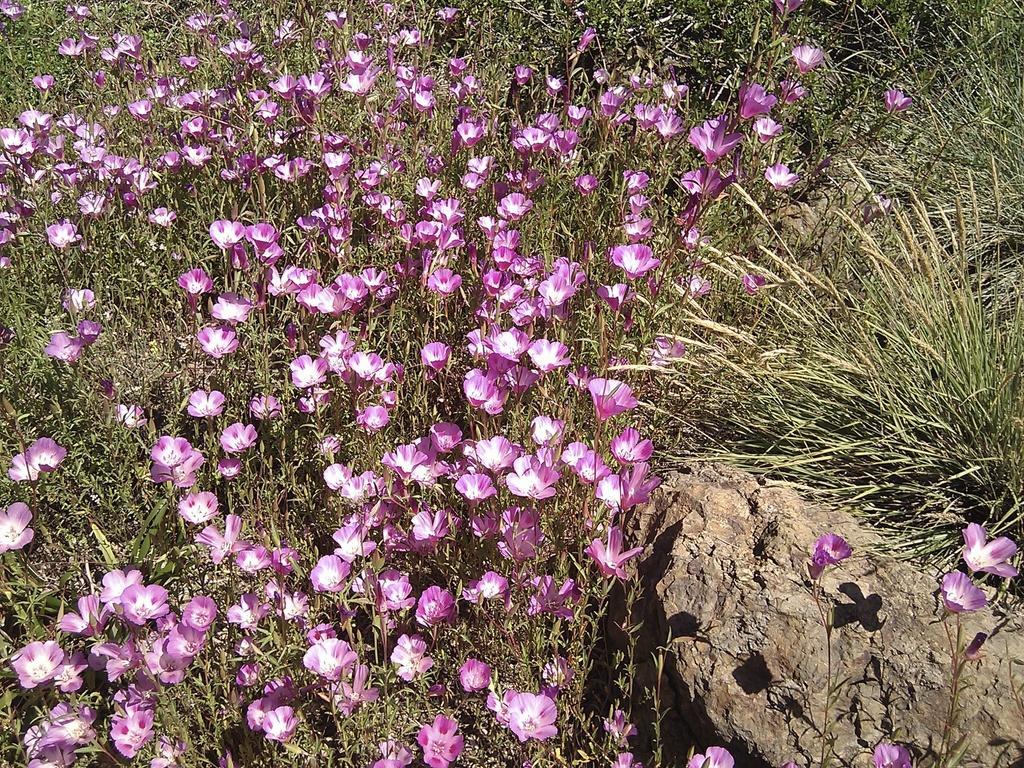Can you describe this image briefly? In this image we can see there are plants with flowers and there is a stone and grass. 